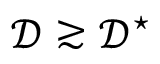Convert formula to latex. <formula><loc_0><loc_0><loc_500><loc_500>\mathcal { D } \gtrsim \mathcal { D } ^ { ^ { * } }</formula> 